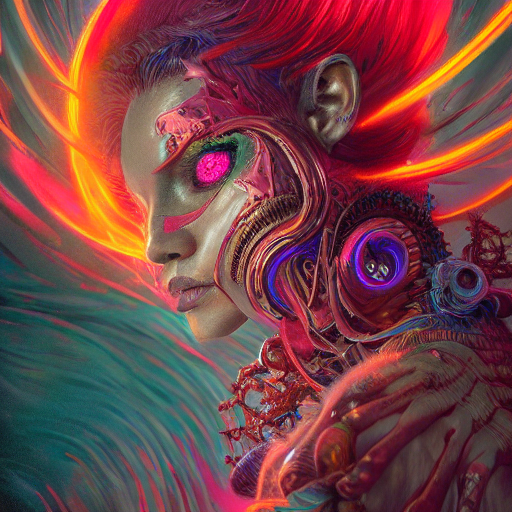What is the theme depicted in this image? The image explores the fusion of organic life with technology, possibly representing a concept of the future where humans and machines integrate. It invokes a sense of cybernetic enhancement and transhumanism. 